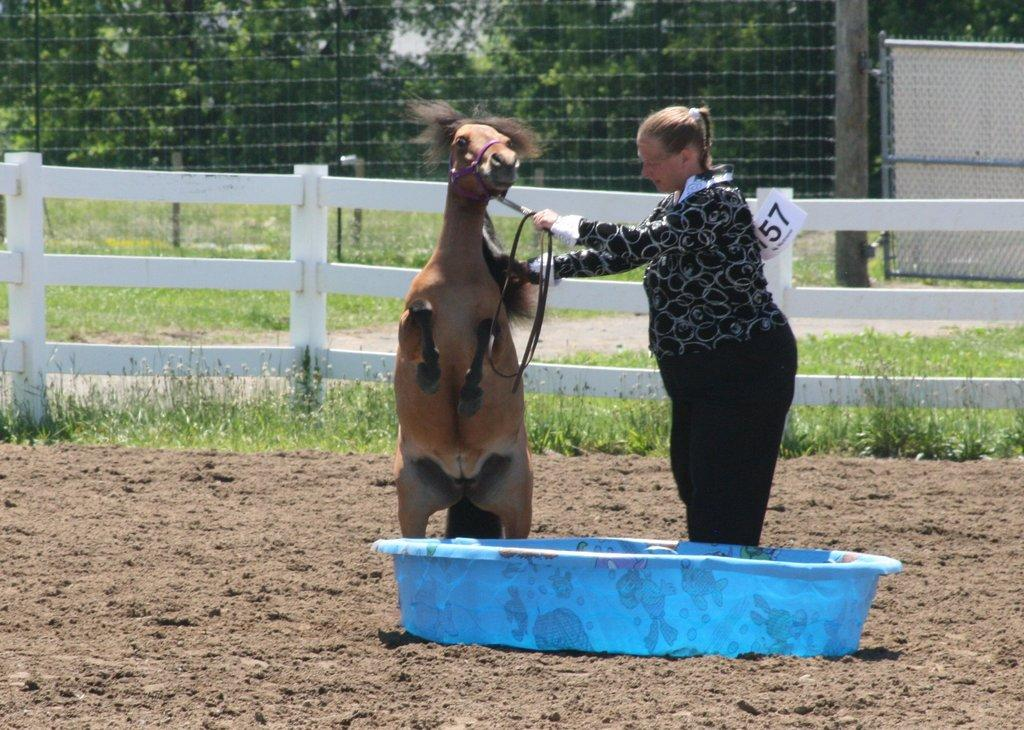What object can be seen on the land in the image? There is a blue color tub on the land in the image. Who is present in the image? There is a woman in the image. What animal is also present in the image? There is a horse in the image. Where are the woman and the horse located in the image? The woman and the horse are in the middle of the image. What can be seen in the background of the image? There is a fence, trees, and a gate in the background of the image. What type of lamp is hanging from the tree in the image? There is no lamp present in the image; it features a blue tub, a woman, a horse, and a background with a fence, trees, and a gate. What advertisement can be seen on the horse's back in the image? There is no advertisement present on the horse's back in the image. 